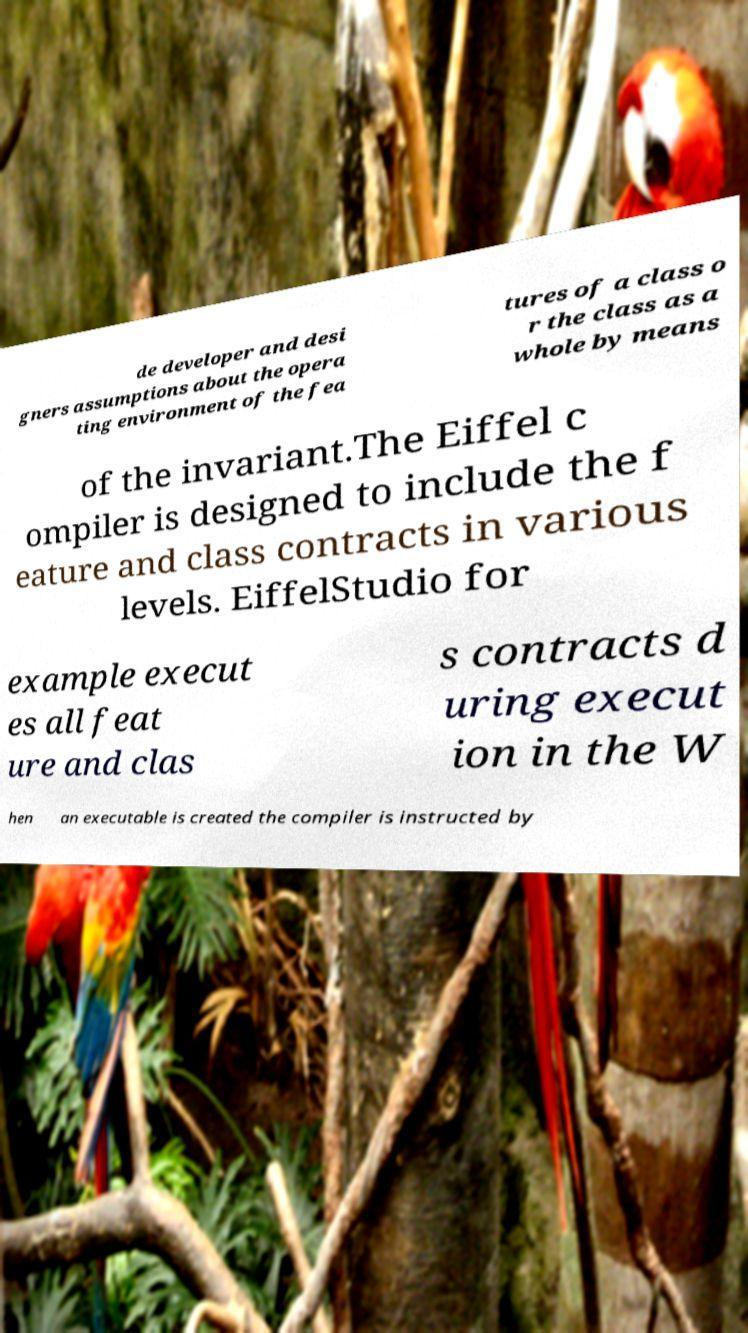Please identify and transcribe the text found in this image. de developer and desi gners assumptions about the opera ting environment of the fea tures of a class o r the class as a whole by means of the invariant.The Eiffel c ompiler is designed to include the f eature and class contracts in various levels. EiffelStudio for example execut es all feat ure and clas s contracts d uring execut ion in the W hen an executable is created the compiler is instructed by 